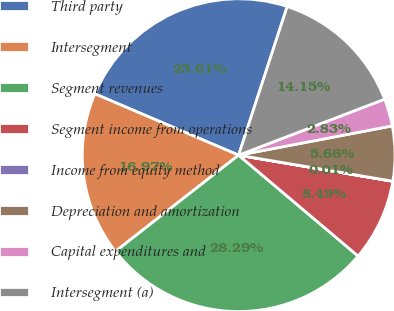<chart> <loc_0><loc_0><loc_500><loc_500><pie_chart><fcel>Third party<fcel>Intersegment<fcel>Segment revenues<fcel>Segment income from operations<fcel>Income from equity method<fcel>Depreciation and amortization<fcel>Capital expenditures and<fcel>Intersegment (a)<nl><fcel>23.61%<fcel>16.97%<fcel>28.29%<fcel>8.49%<fcel>0.01%<fcel>5.66%<fcel>2.83%<fcel>14.15%<nl></chart> 